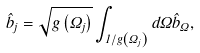Convert formula to latex. <formula><loc_0><loc_0><loc_500><loc_500>\hat { b } _ { j } = \sqrt { g \left ( \Omega _ { j } \right ) } \int _ { 1 / g \left ( \Omega _ { j } \right ) } d \Omega \hat { b } _ { \Omega } ,</formula> 